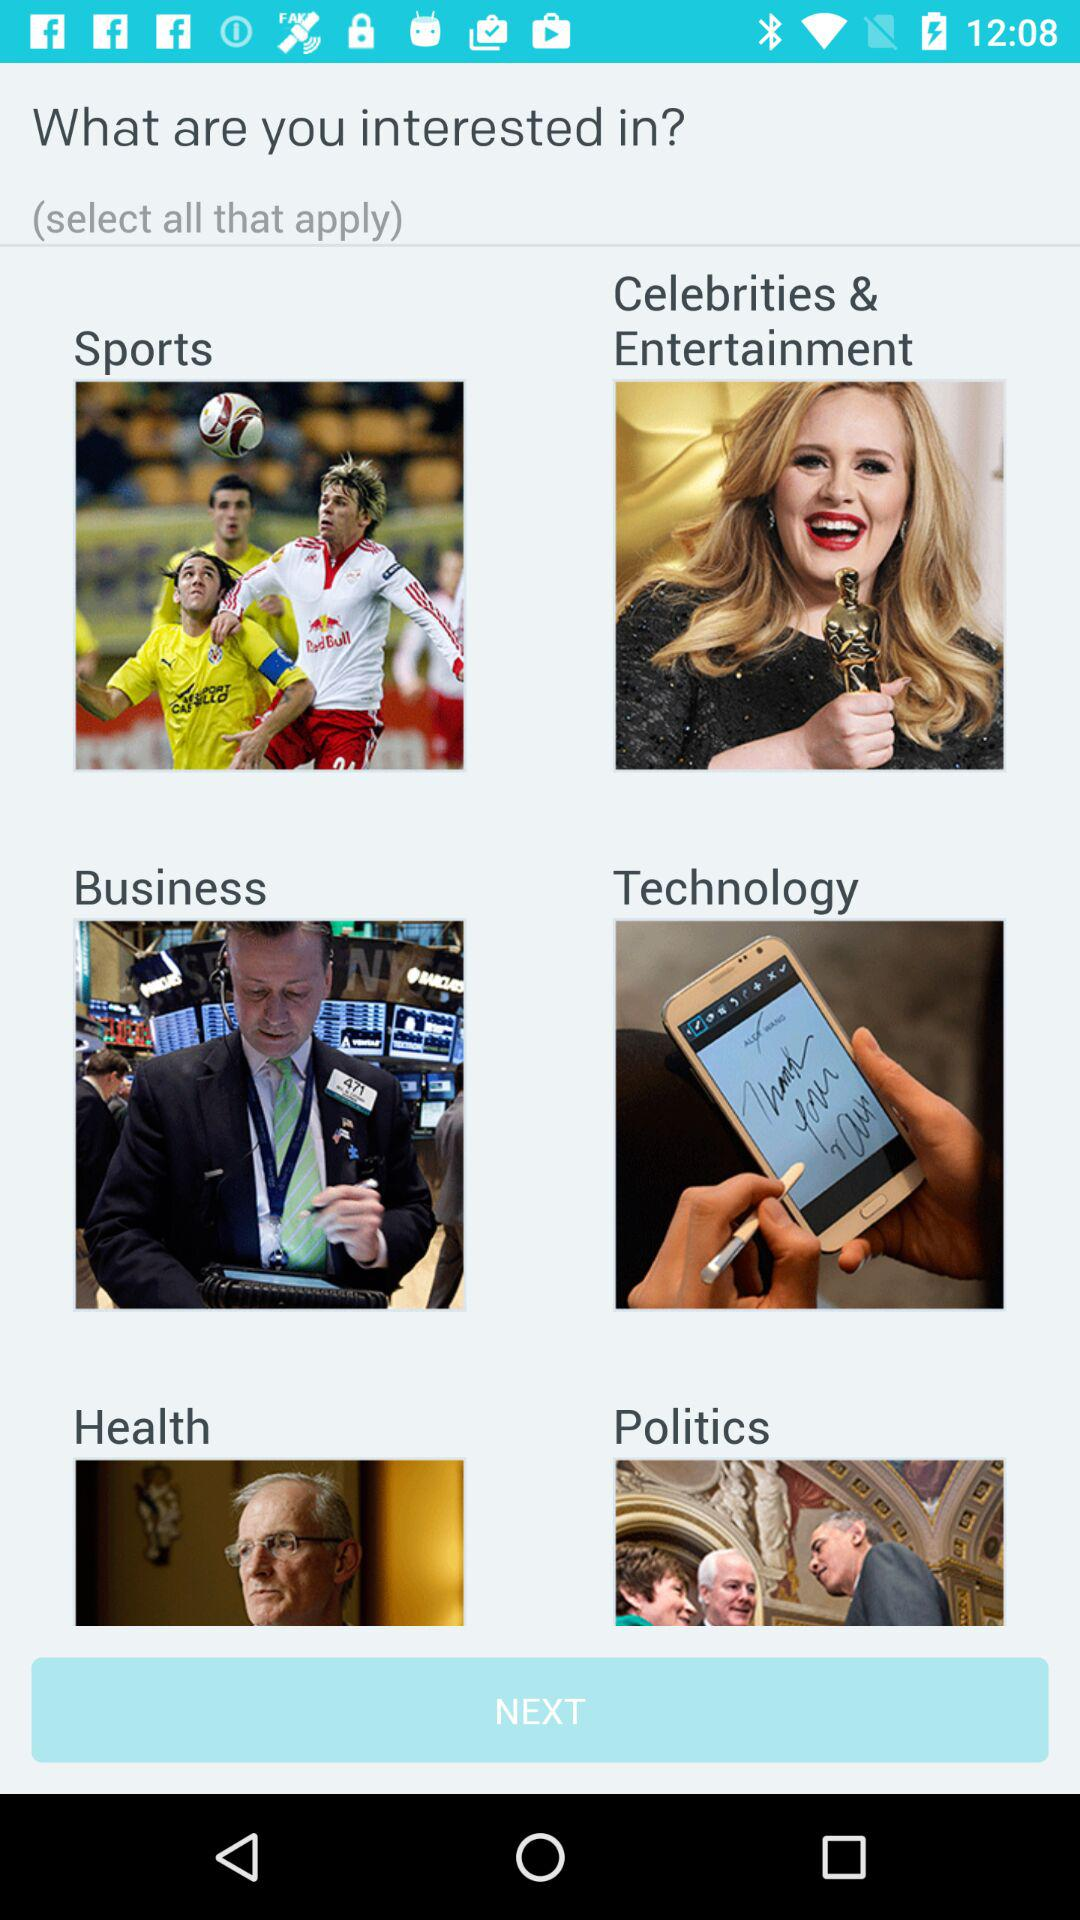How many categories are there in total?
Answer the question using a single word or phrase. 6 